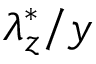Convert formula to latex. <formula><loc_0><loc_0><loc_500><loc_500>\lambda _ { z } ^ { * } / y</formula> 